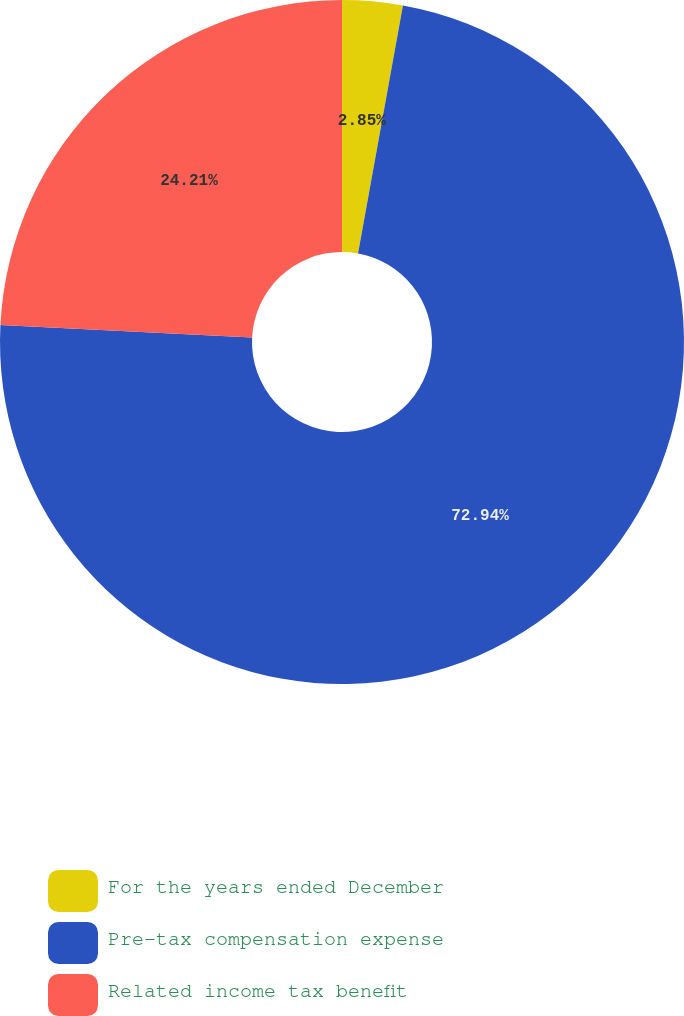Convert chart. <chart><loc_0><loc_0><loc_500><loc_500><pie_chart><fcel>For the years ended December<fcel>Pre-tax compensation expense<fcel>Related income tax benefit<nl><fcel>2.85%<fcel>72.93%<fcel>24.21%<nl></chart> 